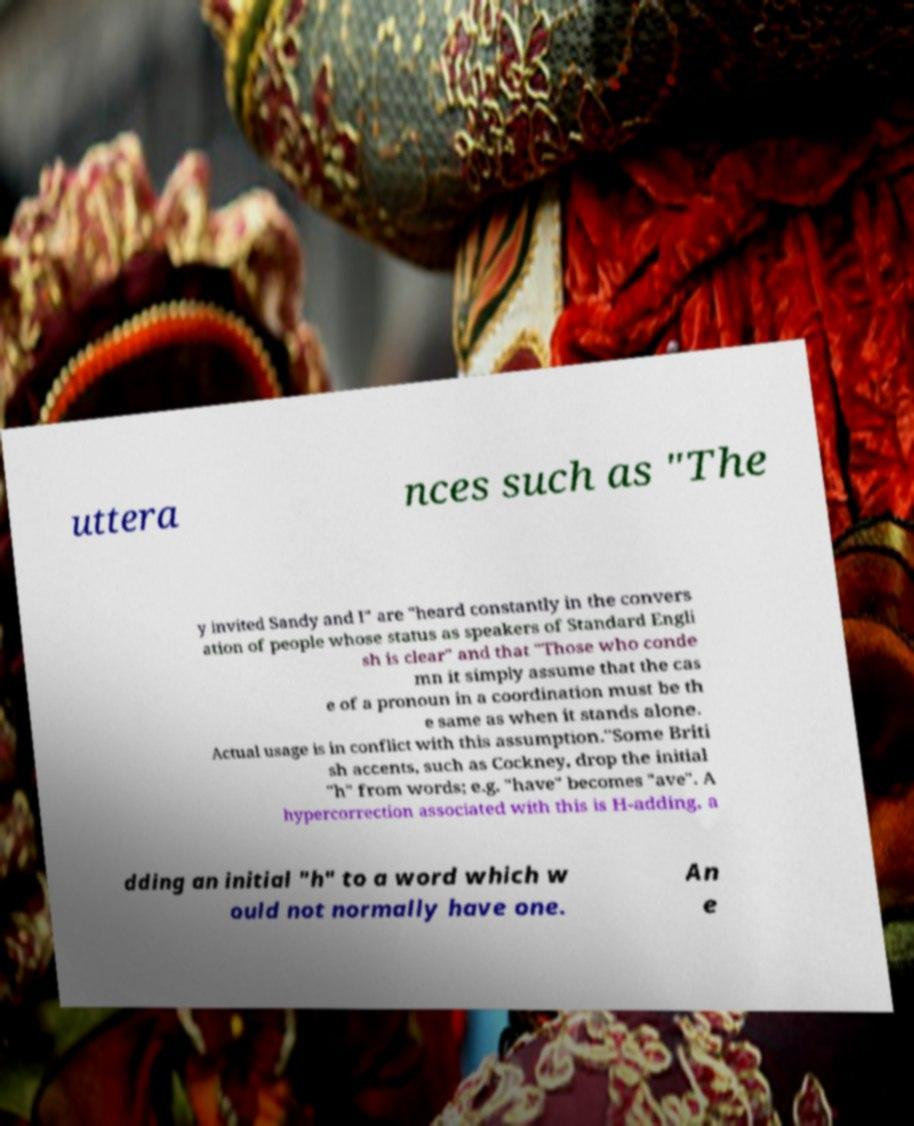Please identify and transcribe the text found in this image. uttera nces such as "The y invited Sandy and I" are "heard constantly in the convers ation of people whose status as speakers of Standard Engli sh is clear" and that "Those who conde mn it simply assume that the cas e of a pronoun in a coordination must be th e same as when it stands alone. Actual usage is in conflict with this assumption."Some Briti sh accents, such as Cockney, drop the initial "h" from words; e.g. "have" becomes "ave". A hypercorrection associated with this is H-adding, a dding an initial "h" to a word which w ould not normally have one. An e 